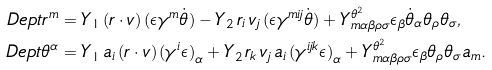<formula> <loc_0><loc_0><loc_500><loc_500>\ D e p t r ^ { m } & = { Y _ { 1 } } \, ( r \cdot v ) \, ( \epsilon { { \gamma } ^ { m } } { \dot { \theta } } ) - { Y _ { 2 } } \, { r _ { i } } \, { v _ { j } } \, ( \epsilon { { \gamma } ^ { m i j } } { \dot { \theta } } ) + Y _ { m \alpha \beta \rho \sigma } ^ { \theta ^ { 2 } } \epsilon _ { \beta } \dot { \theta } _ { \alpha } \theta _ { \rho } \theta _ { \sigma } , \\ \ D e p t \theta ^ { \alpha } & = { Y _ { 1 } } \, { a _ { i } } \, ( r \cdot v ) \, { { ( { { \gamma } ^ { i } } \epsilon ) } _ { \alpha } } + { Y _ { 2 } } \, { r _ { k } } \, { v _ { j } } \, { a _ { i } } \, { { ( { { \gamma } ^ { i j k } } \epsilon ) } _ { \alpha } } + Y _ { m \alpha \beta \rho \sigma } ^ { \theta ^ { 2 } } \epsilon _ { \beta } \theta _ { \rho } \theta _ { \sigma } a _ { m } .</formula> 